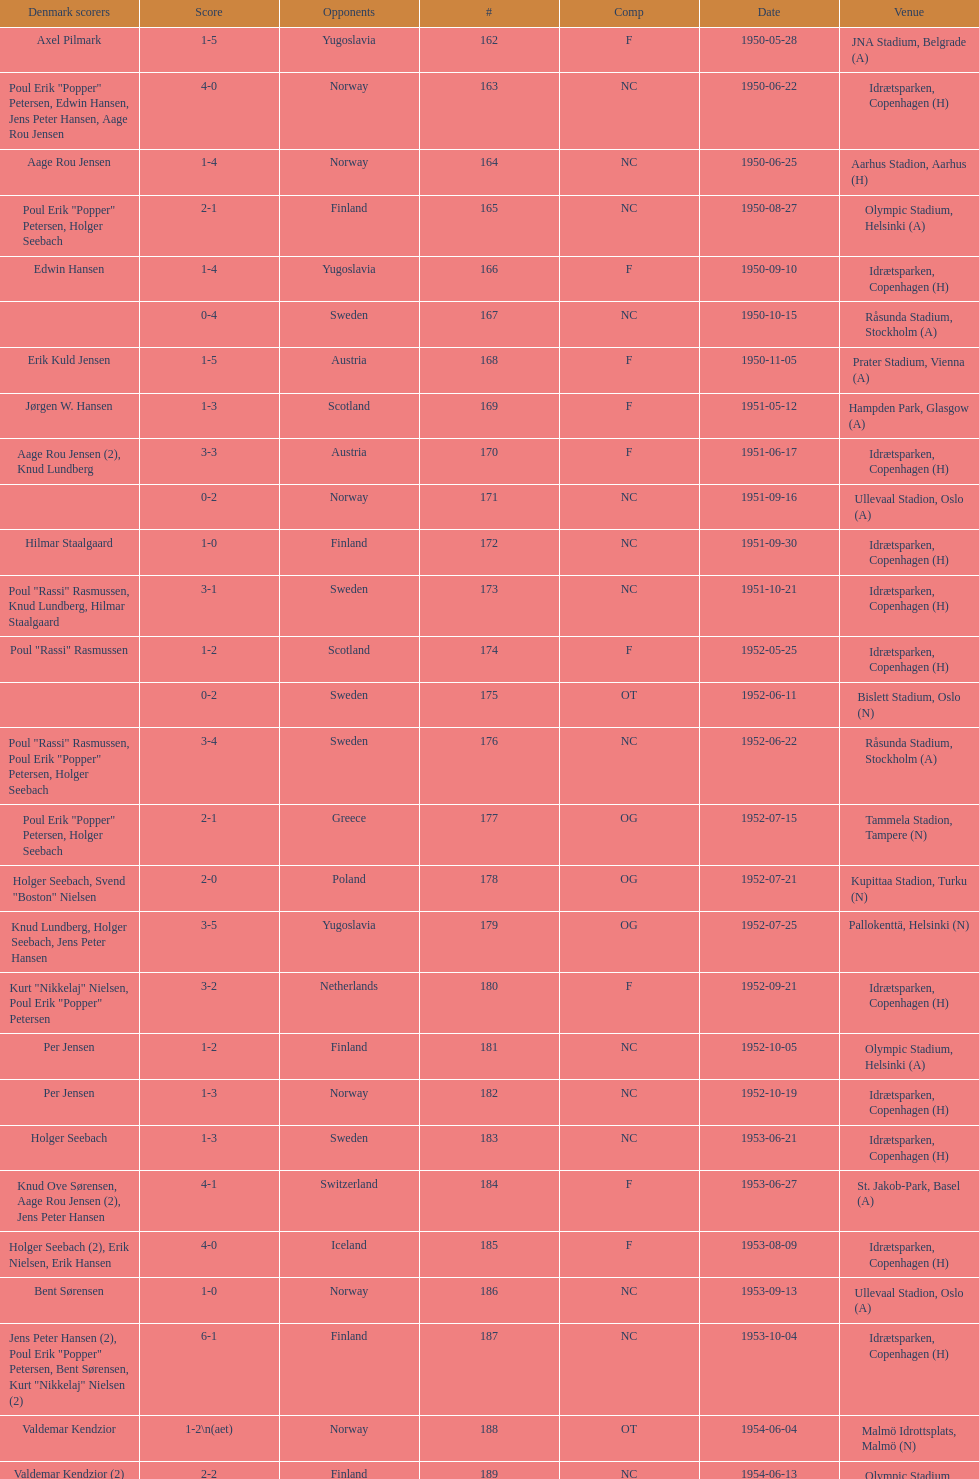Is denmark superior when competing against sweden or england? Sweden. 